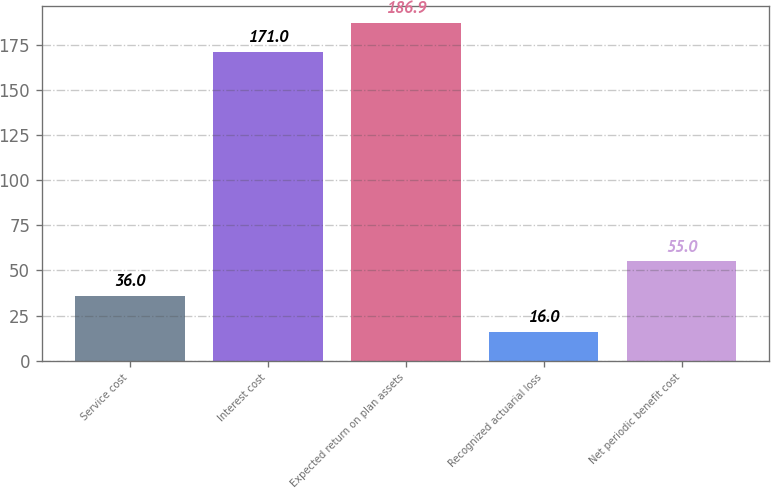<chart> <loc_0><loc_0><loc_500><loc_500><bar_chart><fcel>Service cost<fcel>Interest cost<fcel>Expected return on plan assets<fcel>Recognized actuarial loss<fcel>Net periodic benefit cost<nl><fcel>36<fcel>171<fcel>186.9<fcel>16<fcel>55<nl></chart> 